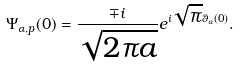<formula> <loc_0><loc_0><loc_500><loc_500>\Psi _ { \alpha , p } ( 0 ) = \frac { \mp i } { \sqrt { 2 \pi a } } e ^ { i \sqrt { \pi } \theta _ { \alpha } ( 0 ) } .</formula> 